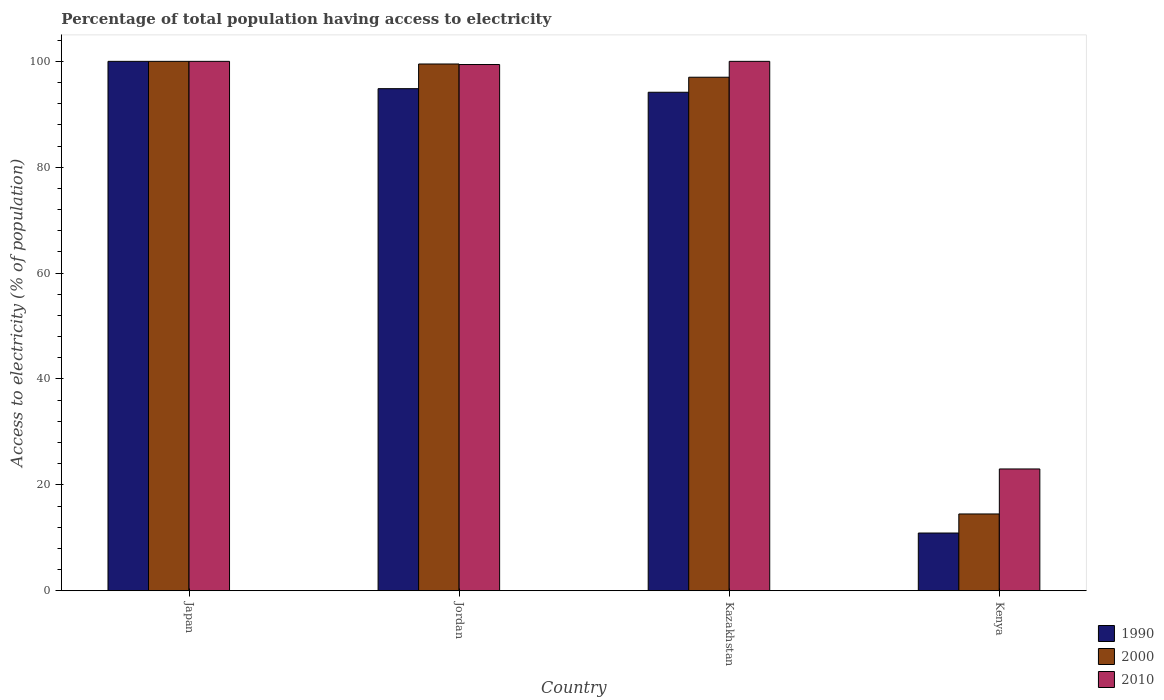How many different coloured bars are there?
Keep it short and to the point. 3. How many groups of bars are there?
Provide a short and direct response. 4. How many bars are there on the 4th tick from the left?
Your answer should be compact. 3. What is the label of the 3rd group of bars from the left?
Make the answer very short. Kazakhstan. What is the percentage of population that have access to electricity in 2010 in Jordan?
Give a very brief answer. 99.4. Across all countries, what is the minimum percentage of population that have access to electricity in 2010?
Keep it short and to the point. 23. In which country was the percentage of population that have access to electricity in 2010 maximum?
Your answer should be compact. Japan. In which country was the percentage of population that have access to electricity in 2000 minimum?
Give a very brief answer. Kenya. What is the total percentage of population that have access to electricity in 2000 in the graph?
Offer a terse response. 311. What is the difference between the percentage of population that have access to electricity in 2000 in Japan and that in Jordan?
Provide a succinct answer. 0.5. What is the difference between the percentage of population that have access to electricity in 2010 in Japan and the percentage of population that have access to electricity in 1990 in Kazakhstan?
Provide a succinct answer. 5.84. What is the average percentage of population that have access to electricity in 2000 per country?
Your response must be concise. 77.75. What is the difference between the percentage of population that have access to electricity of/in 2010 and percentage of population that have access to electricity of/in 1990 in Kenya?
Ensure brevity in your answer.  12.1. What is the ratio of the percentage of population that have access to electricity in 1990 in Kazakhstan to that in Kenya?
Offer a terse response. 8.64. Is the difference between the percentage of population that have access to electricity in 2010 in Jordan and Kazakhstan greater than the difference between the percentage of population that have access to electricity in 1990 in Jordan and Kazakhstan?
Make the answer very short. No. What is the difference between the highest and the second highest percentage of population that have access to electricity in 1990?
Make the answer very short. -5.84. What is the difference between the highest and the lowest percentage of population that have access to electricity in 1990?
Keep it short and to the point. 89.1. What does the 2nd bar from the left in Kenya represents?
Your response must be concise. 2000. What does the 3rd bar from the right in Kenya represents?
Your answer should be compact. 1990. Is it the case that in every country, the sum of the percentage of population that have access to electricity in 1990 and percentage of population that have access to electricity in 2000 is greater than the percentage of population that have access to electricity in 2010?
Make the answer very short. Yes. How many bars are there?
Your response must be concise. 12. Are all the bars in the graph horizontal?
Your response must be concise. No. How many countries are there in the graph?
Your answer should be very brief. 4. What is the difference between two consecutive major ticks on the Y-axis?
Provide a short and direct response. 20. Does the graph contain any zero values?
Keep it short and to the point. No. Does the graph contain grids?
Make the answer very short. No. How many legend labels are there?
Give a very brief answer. 3. How are the legend labels stacked?
Provide a short and direct response. Vertical. What is the title of the graph?
Offer a terse response. Percentage of total population having access to electricity. What is the label or title of the X-axis?
Your answer should be compact. Country. What is the label or title of the Y-axis?
Ensure brevity in your answer.  Access to electricity (% of population). What is the Access to electricity (% of population) in 2000 in Japan?
Your response must be concise. 100. What is the Access to electricity (% of population) in 2010 in Japan?
Offer a very short reply. 100. What is the Access to electricity (% of population) of 1990 in Jordan?
Ensure brevity in your answer.  94.84. What is the Access to electricity (% of population) of 2000 in Jordan?
Provide a succinct answer. 99.5. What is the Access to electricity (% of population) in 2010 in Jordan?
Provide a short and direct response. 99.4. What is the Access to electricity (% of population) of 1990 in Kazakhstan?
Give a very brief answer. 94.16. What is the Access to electricity (% of population) of 2000 in Kazakhstan?
Give a very brief answer. 97. What is the Access to electricity (% of population) in 2010 in Kazakhstan?
Make the answer very short. 100. What is the Access to electricity (% of population) in 1990 in Kenya?
Keep it short and to the point. 10.9. Across all countries, what is the maximum Access to electricity (% of population) in 1990?
Your answer should be very brief. 100. Across all countries, what is the maximum Access to electricity (% of population) of 2010?
Provide a succinct answer. 100. Across all countries, what is the minimum Access to electricity (% of population) in 2000?
Make the answer very short. 14.5. What is the total Access to electricity (% of population) of 1990 in the graph?
Offer a terse response. 299.9. What is the total Access to electricity (% of population) in 2000 in the graph?
Make the answer very short. 311. What is the total Access to electricity (% of population) in 2010 in the graph?
Your answer should be compact. 322.4. What is the difference between the Access to electricity (% of population) of 1990 in Japan and that in Jordan?
Ensure brevity in your answer.  5.16. What is the difference between the Access to electricity (% of population) in 2000 in Japan and that in Jordan?
Provide a succinct answer. 0.5. What is the difference between the Access to electricity (% of population) of 1990 in Japan and that in Kazakhstan?
Your answer should be very brief. 5.84. What is the difference between the Access to electricity (% of population) of 2000 in Japan and that in Kazakhstan?
Make the answer very short. 3. What is the difference between the Access to electricity (% of population) in 1990 in Japan and that in Kenya?
Your answer should be compact. 89.1. What is the difference between the Access to electricity (% of population) of 2000 in Japan and that in Kenya?
Offer a terse response. 85.5. What is the difference between the Access to electricity (% of population) of 1990 in Jordan and that in Kazakhstan?
Your response must be concise. 0.68. What is the difference between the Access to electricity (% of population) of 2010 in Jordan and that in Kazakhstan?
Give a very brief answer. -0.6. What is the difference between the Access to electricity (% of population) of 1990 in Jordan and that in Kenya?
Your response must be concise. 83.94. What is the difference between the Access to electricity (% of population) of 2010 in Jordan and that in Kenya?
Your response must be concise. 76.4. What is the difference between the Access to electricity (% of population) in 1990 in Kazakhstan and that in Kenya?
Your answer should be very brief. 83.26. What is the difference between the Access to electricity (% of population) of 2000 in Kazakhstan and that in Kenya?
Provide a succinct answer. 82.5. What is the difference between the Access to electricity (% of population) in 1990 in Japan and the Access to electricity (% of population) in 2000 in Jordan?
Your response must be concise. 0.5. What is the difference between the Access to electricity (% of population) in 1990 in Japan and the Access to electricity (% of population) in 2000 in Kazakhstan?
Your answer should be compact. 3. What is the difference between the Access to electricity (% of population) in 1990 in Japan and the Access to electricity (% of population) in 2000 in Kenya?
Provide a succinct answer. 85.5. What is the difference between the Access to electricity (% of population) of 1990 in Jordan and the Access to electricity (% of population) of 2000 in Kazakhstan?
Offer a terse response. -2.16. What is the difference between the Access to electricity (% of population) in 1990 in Jordan and the Access to electricity (% of population) in 2010 in Kazakhstan?
Your response must be concise. -5.16. What is the difference between the Access to electricity (% of population) of 1990 in Jordan and the Access to electricity (% of population) of 2000 in Kenya?
Your answer should be compact. 80.34. What is the difference between the Access to electricity (% of population) in 1990 in Jordan and the Access to electricity (% of population) in 2010 in Kenya?
Keep it short and to the point. 71.84. What is the difference between the Access to electricity (% of population) in 2000 in Jordan and the Access to electricity (% of population) in 2010 in Kenya?
Make the answer very short. 76.5. What is the difference between the Access to electricity (% of population) in 1990 in Kazakhstan and the Access to electricity (% of population) in 2000 in Kenya?
Offer a very short reply. 79.66. What is the difference between the Access to electricity (% of population) in 1990 in Kazakhstan and the Access to electricity (% of population) in 2010 in Kenya?
Keep it short and to the point. 71.16. What is the difference between the Access to electricity (% of population) in 2000 in Kazakhstan and the Access to electricity (% of population) in 2010 in Kenya?
Your answer should be very brief. 74. What is the average Access to electricity (% of population) of 1990 per country?
Keep it short and to the point. 74.97. What is the average Access to electricity (% of population) in 2000 per country?
Provide a short and direct response. 77.75. What is the average Access to electricity (% of population) of 2010 per country?
Ensure brevity in your answer.  80.6. What is the difference between the Access to electricity (% of population) in 1990 and Access to electricity (% of population) in 2000 in Japan?
Your response must be concise. 0. What is the difference between the Access to electricity (% of population) in 1990 and Access to electricity (% of population) in 2000 in Jordan?
Offer a very short reply. -4.66. What is the difference between the Access to electricity (% of population) in 1990 and Access to electricity (% of population) in 2010 in Jordan?
Keep it short and to the point. -4.56. What is the difference between the Access to electricity (% of population) in 2000 and Access to electricity (% of population) in 2010 in Jordan?
Offer a terse response. 0.1. What is the difference between the Access to electricity (% of population) of 1990 and Access to electricity (% of population) of 2000 in Kazakhstan?
Your answer should be very brief. -2.84. What is the difference between the Access to electricity (% of population) in 1990 and Access to electricity (% of population) in 2010 in Kazakhstan?
Your answer should be very brief. -5.84. What is the difference between the Access to electricity (% of population) in 2000 and Access to electricity (% of population) in 2010 in Kazakhstan?
Keep it short and to the point. -3. What is the difference between the Access to electricity (% of population) of 2000 and Access to electricity (% of population) of 2010 in Kenya?
Keep it short and to the point. -8.5. What is the ratio of the Access to electricity (% of population) in 1990 in Japan to that in Jordan?
Make the answer very short. 1.05. What is the ratio of the Access to electricity (% of population) of 2000 in Japan to that in Jordan?
Your answer should be compact. 1. What is the ratio of the Access to electricity (% of population) in 1990 in Japan to that in Kazakhstan?
Provide a succinct answer. 1.06. What is the ratio of the Access to electricity (% of population) in 2000 in Japan to that in Kazakhstan?
Your answer should be compact. 1.03. What is the ratio of the Access to electricity (% of population) in 1990 in Japan to that in Kenya?
Your response must be concise. 9.17. What is the ratio of the Access to electricity (% of population) in 2000 in Japan to that in Kenya?
Your response must be concise. 6.9. What is the ratio of the Access to electricity (% of population) in 2010 in Japan to that in Kenya?
Your answer should be compact. 4.35. What is the ratio of the Access to electricity (% of population) in 2000 in Jordan to that in Kazakhstan?
Your response must be concise. 1.03. What is the ratio of the Access to electricity (% of population) of 2010 in Jordan to that in Kazakhstan?
Offer a terse response. 0.99. What is the ratio of the Access to electricity (% of population) in 1990 in Jordan to that in Kenya?
Your answer should be very brief. 8.7. What is the ratio of the Access to electricity (% of population) in 2000 in Jordan to that in Kenya?
Ensure brevity in your answer.  6.86. What is the ratio of the Access to electricity (% of population) of 2010 in Jordan to that in Kenya?
Provide a succinct answer. 4.32. What is the ratio of the Access to electricity (% of population) of 1990 in Kazakhstan to that in Kenya?
Give a very brief answer. 8.64. What is the ratio of the Access to electricity (% of population) of 2000 in Kazakhstan to that in Kenya?
Ensure brevity in your answer.  6.69. What is the ratio of the Access to electricity (% of population) in 2010 in Kazakhstan to that in Kenya?
Ensure brevity in your answer.  4.35. What is the difference between the highest and the second highest Access to electricity (% of population) of 1990?
Offer a very short reply. 5.16. What is the difference between the highest and the second highest Access to electricity (% of population) of 2000?
Your answer should be compact. 0.5. What is the difference between the highest and the lowest Access to electricity (% of population) of 1990?
Your answer should be compact. 89.1. What is the difference between the highest and the lowest Access to electricity (% of population) in 2000?
Offer a terse response. 85.5. What is the difference between the highest and the lowest Access to electricity (% of population) in 2010?
Offer a terse response. 77. 